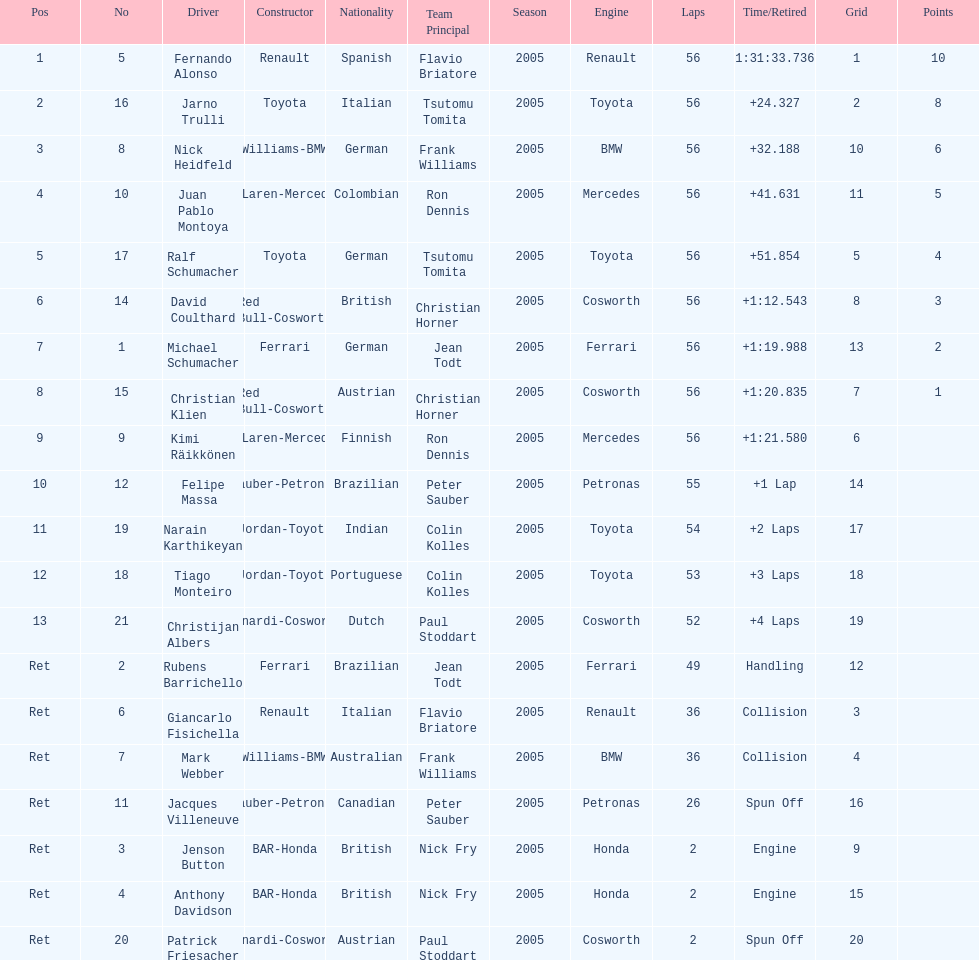Jarno trulli was not french but what nationality? Italian. 